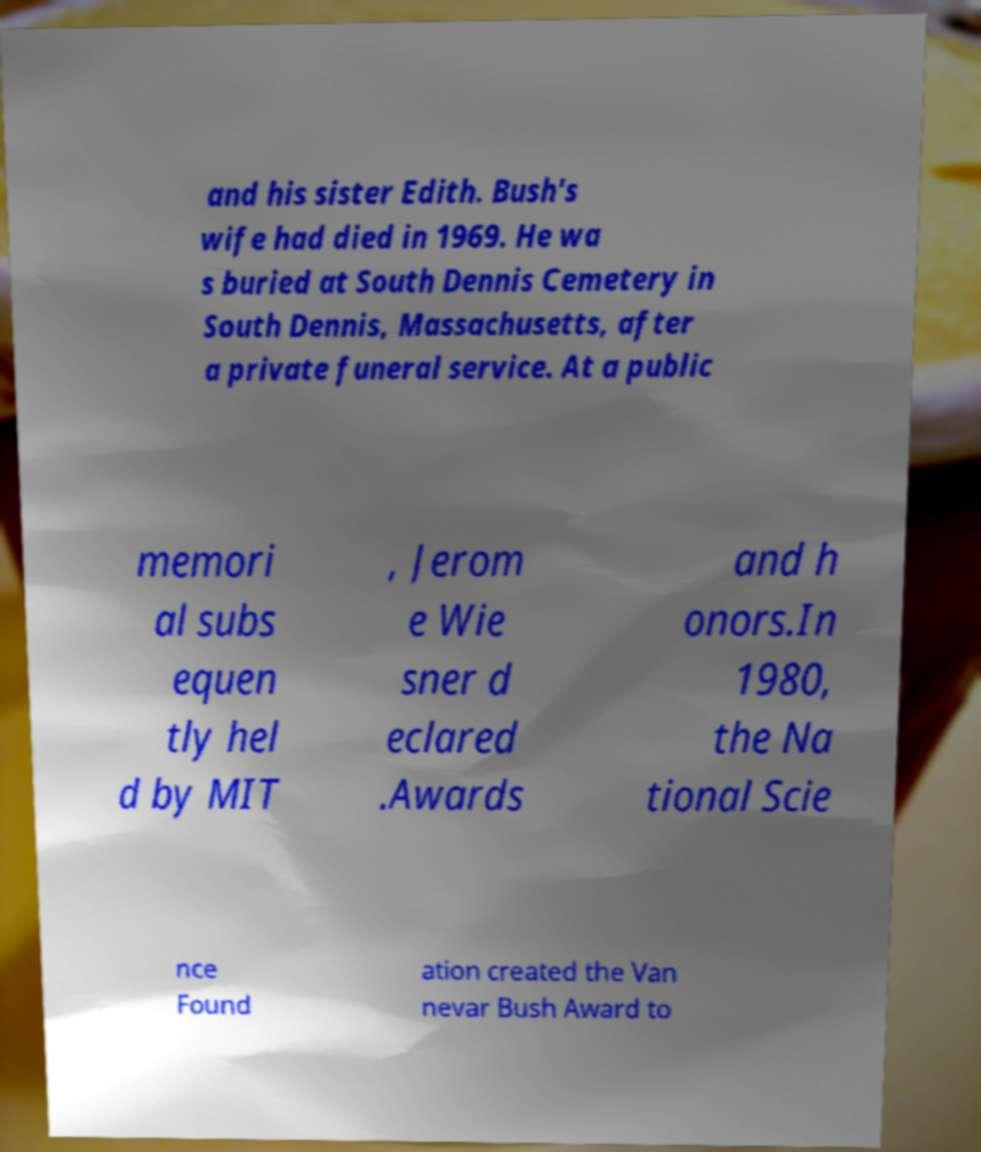What messages or text are displayed in this image? I need them in a readable, typed format. and his sister Edith. Bush's wife had died in 1969. He wa s buried at South Dennis Cemetery in South Dennis, Massachusetts, after a private funeral service. At a public memori al subs equen tly hel d by MIT , Jerom e Wie sner d eclared .Awards and h onors.In 1980, the Na tional Scie nce Found ation created the Van nevar Bush Award to 